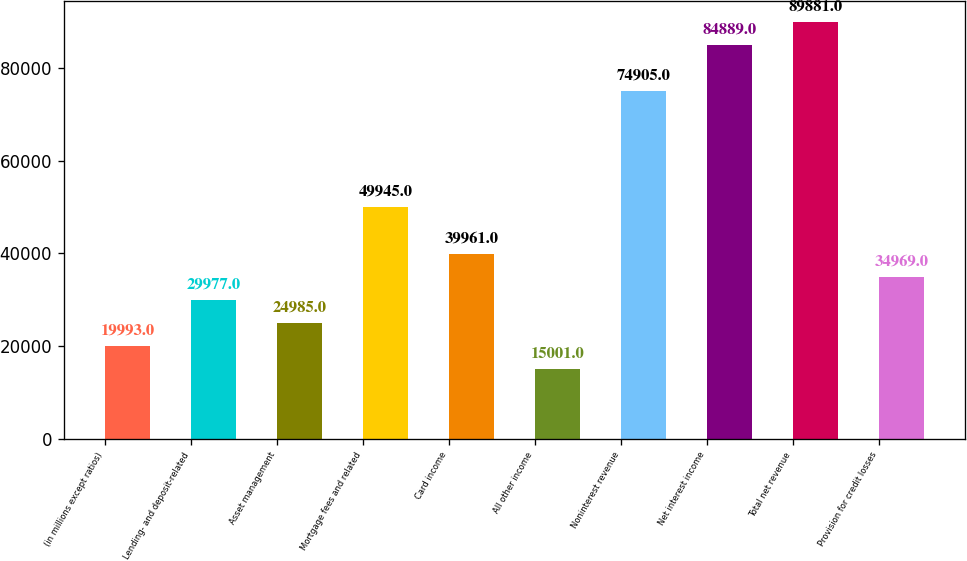Convert chart. <chart><loc_0><loc_0><loc_500><loc_500><bar_chart><fcel>(in millions except ratios)<fcel>Lending- and deposit-related<fcel>Asset management<fcel>Mortgage fees and related<fcel>Card income<fcel>All other income<fcel>Noninterest revenue<fcel>Net interest income<fcel>Total net revenue<fcel>Provision for credit losses<nl><fcel>19993<fcel>29977<fcel>24985<fcel>49945<fcel>39961<fcel>15001<fcel>74905<fcel>84889<fcel>89881<fcel>34969<nl></chart> 